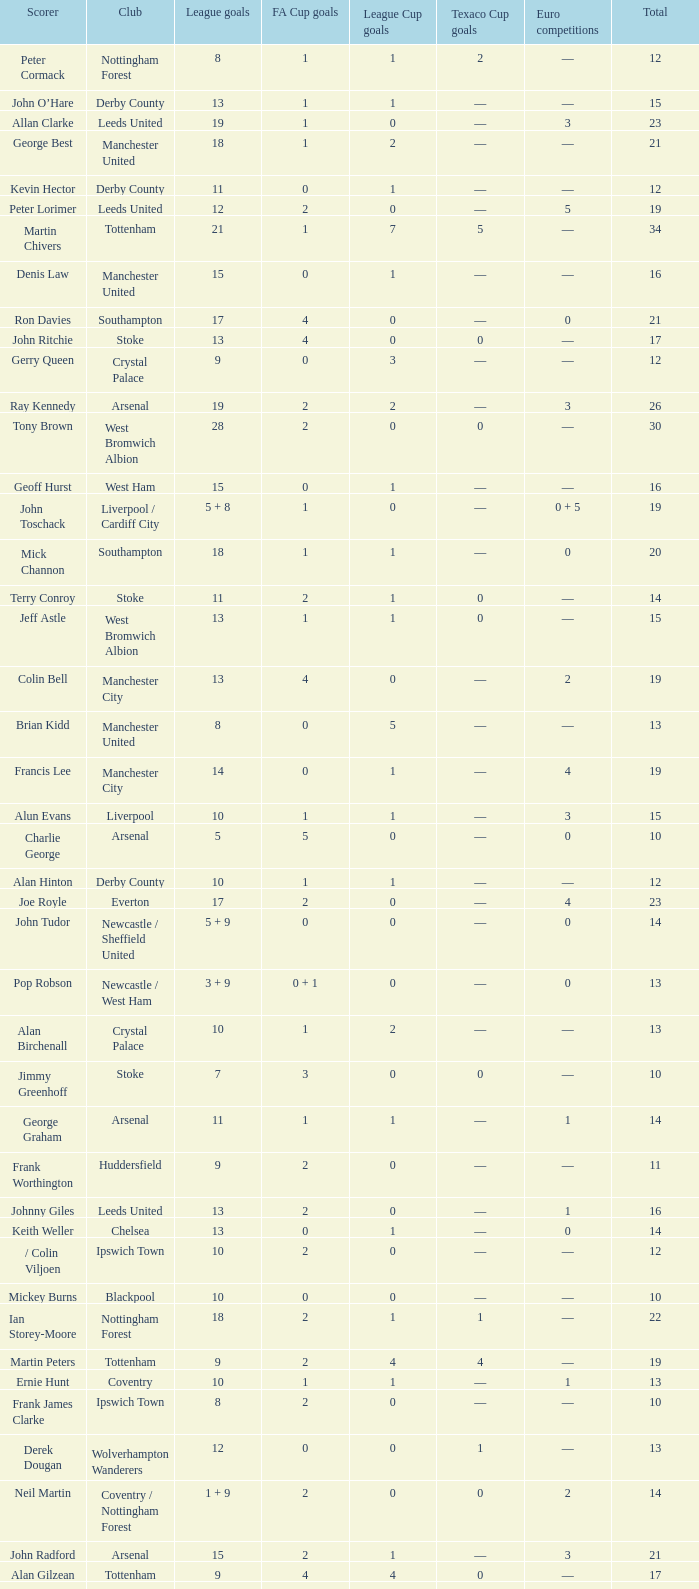What is FA Cup Goals, when Euro Competitions is 1, and when League Goals is 11? 1.0. 